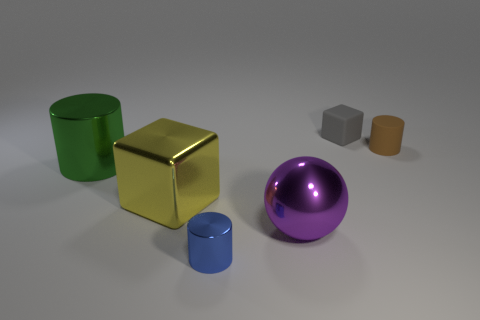How many other things are there of the same color as the metal ball?
Keep it short and to the point. 0. Is the number of small brown matte cylinders left of the small blue cylinder greater than the number of red metal blocks?
Your response must be concise. No. Is the material of the tiny brown thing the same as the large cube?
Ensure brevity in your answer.  No. How many objects are either shiny things in front of the large green cylinder or blue matte spheres?
Keep it short and to the point. 3. How many other objects are there of the same size as the brown rubber object?
Offer a terse response. 2. Are there an equal number of large objects behind the yellow metal object and blue metallic cylinders that are behind the brown matte thing?
Ensure brevity in your answer.  No. There is a small matte object that is the same shape as the large green object; what is its color?
Offer a very short reply. Brown. Is there anything else that has the same shape as the gray thing?
Provide a short and direct response. Yes. There is a tiny rubber object that is right of the tiny block; does it have the same color as the tiny metal thing?
Make the answer very short. No. What is the size of the green thing that is the same shape as the blue metal object?
Your answer should be compact. Large. 